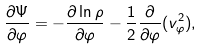Convert formula to latex. <formula><loc_0><loc_0><loc_500><loc_500>\frac { \partial \Psi } { \partial \varphi } = - \frac { \partial \ln \rho } { \partial \varphi } - \frac { 1 } { 2 } \frac { \partial } { \partial \varphi } ( v _ { \varphi } ^ { 2 } ) ,</formula> 